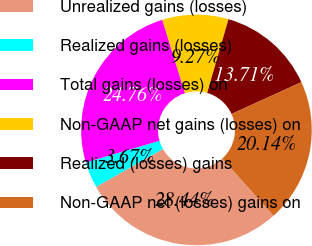Convert chart. <chart><loc_0><loc_0><loc_500><loc_500><pie_chart><fcel>Unrealized gains (losses)<fcel>Realized gains (losses)<fcel>Total gains (losses) on<fcel>Non-GAAP net gains (losses) on<fcel>Realized (losses) gains<fcel>Non-GAAP net (losses) gains on<nl><fcel>28.44%<fcel>3.67%<fcel>24.76%<fcel>9.27%<fcel>13.71%<fcel>20.14%<nl></chart> 